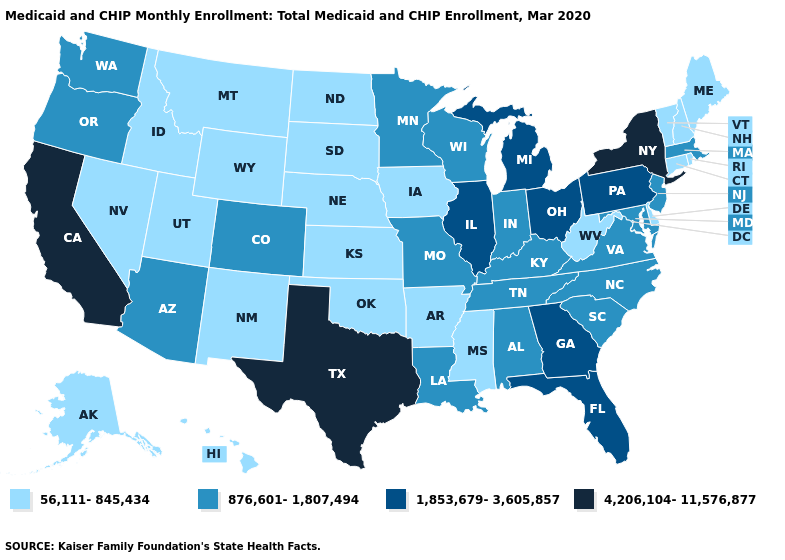What is the value of Minnesota?
Short answer required. 876,601-1,807,494. Does Montana have the same value as Hawaii?
Answer briefly. Yes. Does the first symbol in the legend represent the smallest category?
Keep it brief. Yes. Name the states that have a value in the range 4,206,104-11,576,877?
Short answer required. California, New York, Texas. Does Washington have the highest value in the USA?
Write a very short answer. No. Name the states that have a value in the range 1,853,679-3,605,857?
Answer briefly. Florida, Georgia, Illinois, Michigan, Ohio, Pennsylvania. What is the highest value in the USA?
Be succinct. 4,206,104-11,576,877. What is the highest value in states that border Louisiana?
Write a very short answer. 4,206,104-11,576,877. How many symbols are there in the legend?
Answer briefly. 4. Name the states that have a value in the range 4,206,104-11,576,877?
Keep it brief. California, New York, Texas. Does New York have the highest value in the USA?
Concise answer only. Yes. Does Alabama have the lowest value in the USA?
Be succinct. No. Does Montana have the lowest value in the USA?
Quick response, please. Yes. What is the value of Kentucky?
Quick response, please. 876,601-1,807,494. Does the map have missing data?
Quick response, please. No. 